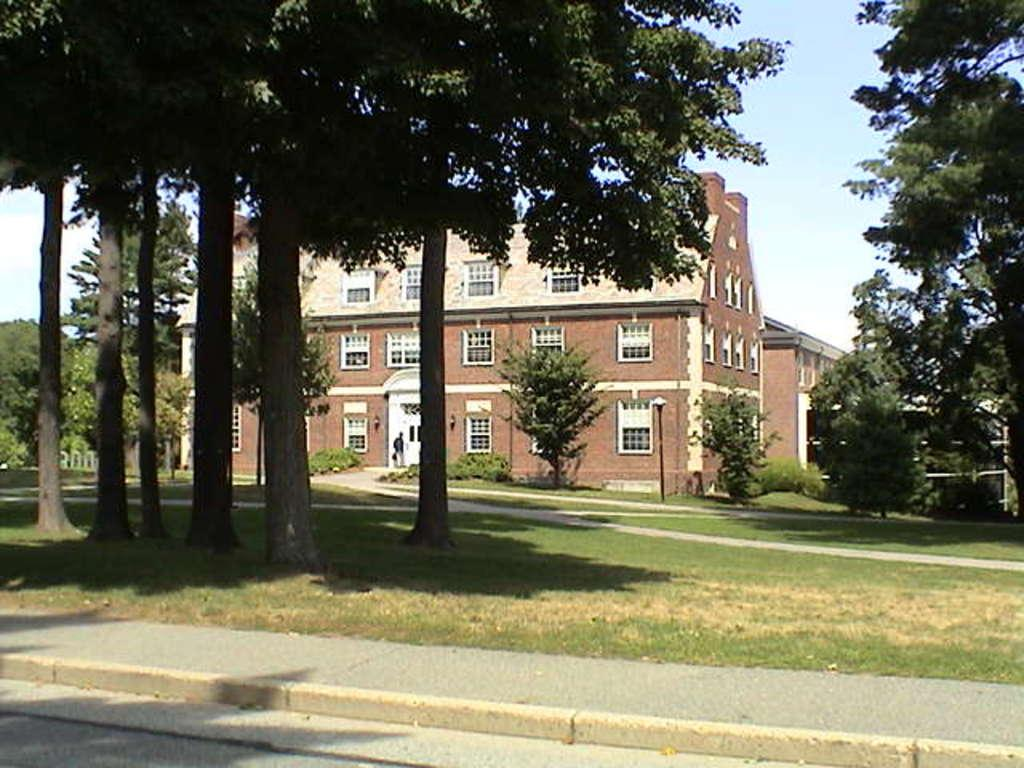What type of vegetation can be seen in the image? There are trees in the image. What type of structures are present in the image? There are buildings in the image. What is visible in the background of the image? The sky is visible in the background of the image. Where is the spade being used to dig in the image? There is no spade or any digging activity present in the image. What type of fuel is being transported by the buildings in the image? There is no indication of any fuel or transportation activity in the image. 